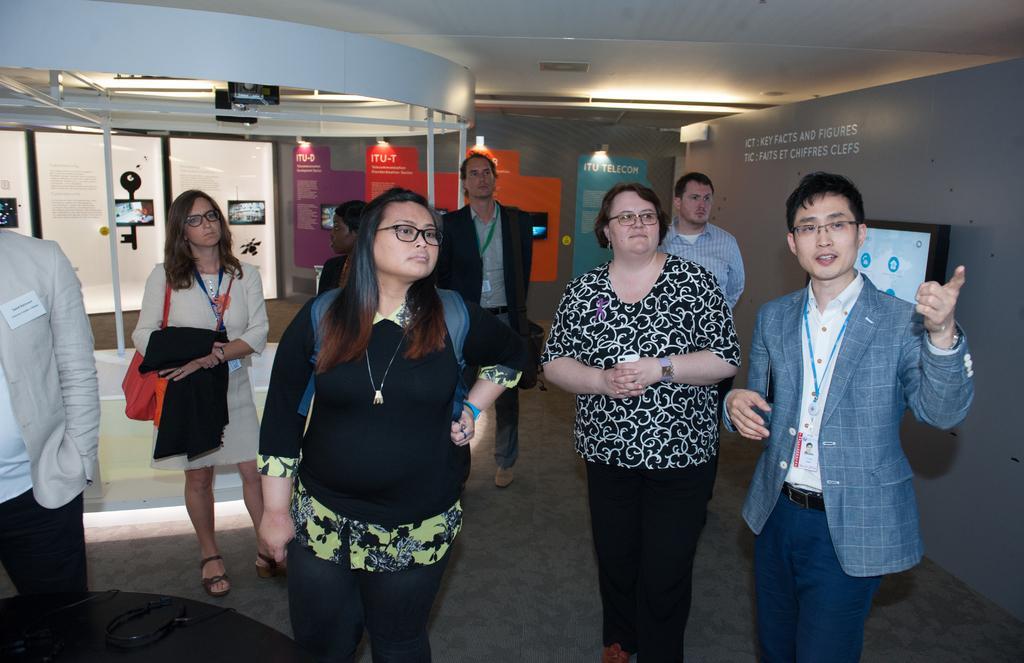Can you describe this image briefly? In this image there are people standing. On the right there is a screen on the wall. In the background there are boards pasted on the wall and there are lights. 